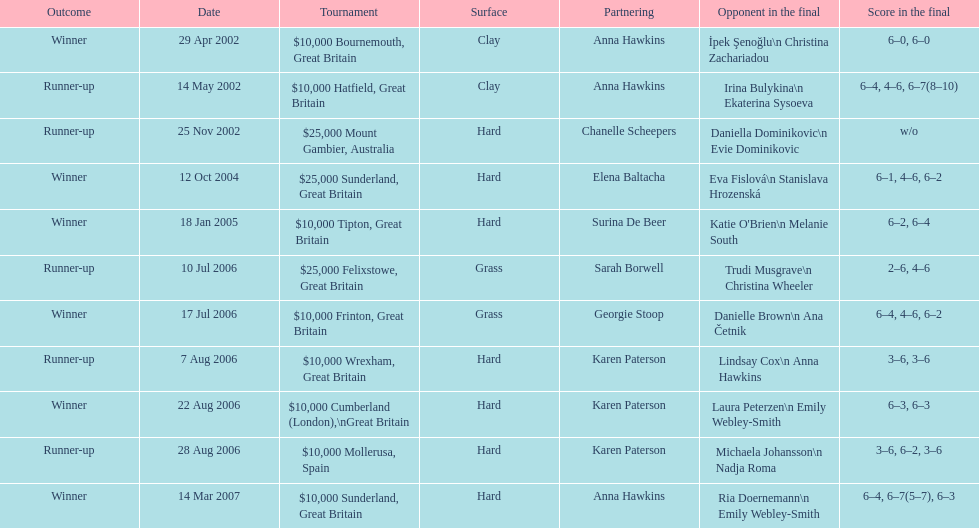What is the number of prize money for the 14 may 2002 tournament? $10,000. 